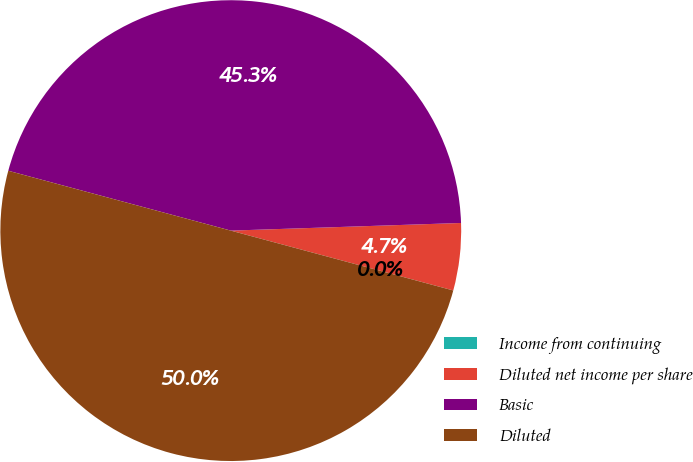<chart> <loc_0><loc_0><loc_500><loc_500><pie_chart><fcel>Income from continuing<fcel>Diluted net income per share<fcel>Basic<fcel>Diluted<nl><fcel>0.0%<fcel>4.71%<fcel>45.29%<fcel>50.0%<nl></chart> 